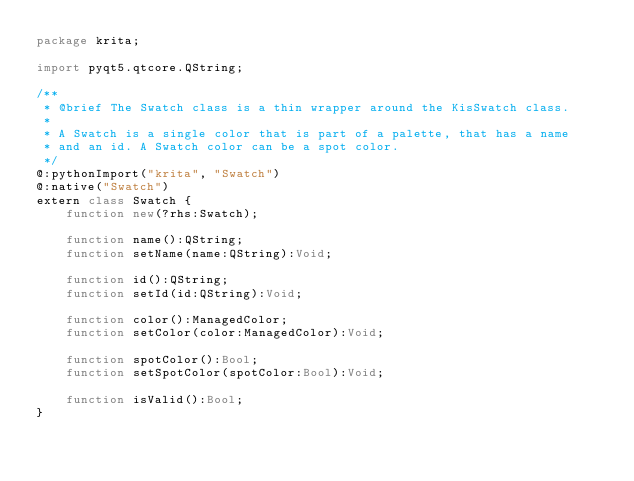Convert code to text. <code><loc_0><loc_0><loc_500><loc_500><_Haxe_>package krita;

import pyqt5.qtcore.QString;

/**
 * @brief The Swatch class is a thin wrapper around the KisSwatch class.
 *
 * A Swatch is a single color that is part of a palette, that has a name
 * and an id. A Swatch color can be a spot color.
 */
@:pythonImport("krita", "Swatch")
@:native("Swatch")
extern class Swatch {
	function new(?rhs:Swatch);

	function name():QString;
	function setName(name:QString):Void;

	function id():QString;
	function setId(id:QString):Void;

	function color():ManagedColor;
	function setColor(color:ManagedColor):Void;

	function spotColor():Bool;
	function setSpotColor(spotColor:Bool):Void;

	function isValid():Bool;
}

</code> 